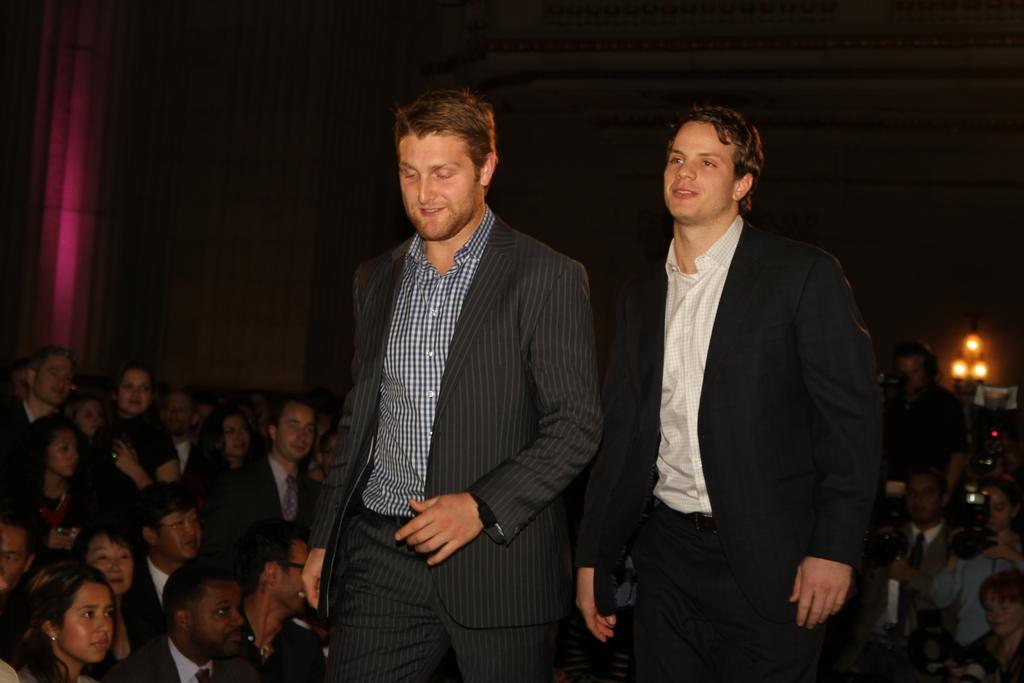In one or two sentences, can you explain what this image depicts? In this image there are two people wearing suit they are walking, in the background people are sitting on chairs and some people are taking photos. 